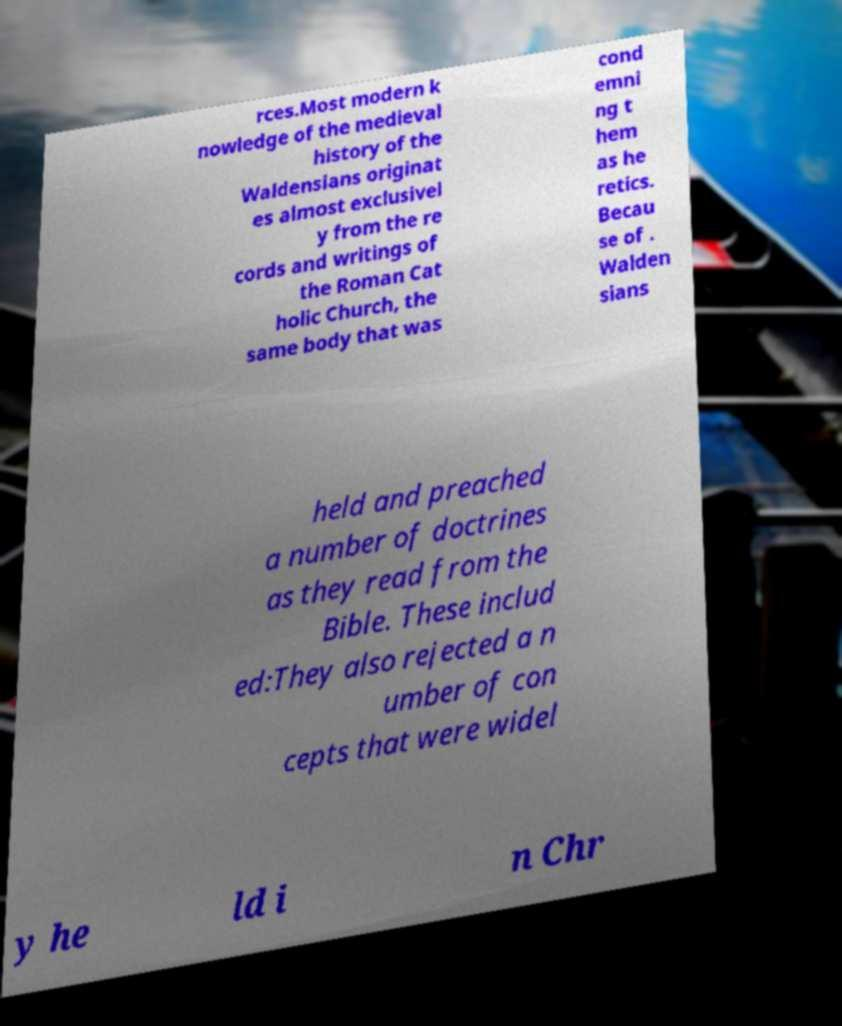What messages or text are displayed in this image? I need them in a readable, typed format. rces.Most modern k nowledge of the medieval history of the Waldensians originat es almost exclusivel y from the re cords and writings of the Roman Cat holic Church, the same body that was cond emni ng t hem as he retics. Becau se of . Walden sians held and preached a number of doctrines as they read from the Bible. These includ ed:They also rejected a n umber of con cepts that were widel y he ld i n Chr 